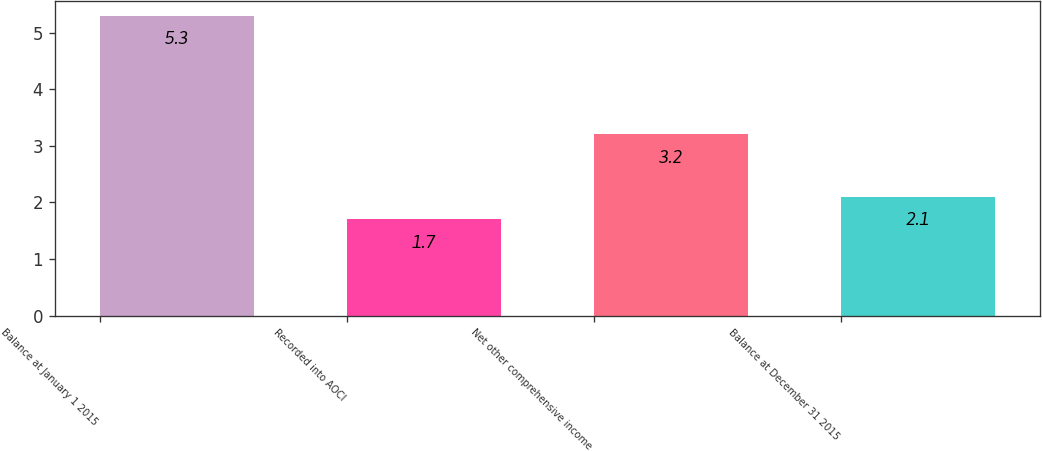Convert chart. <chart><loc_0><loc_0><loc_500><loc_500><bar_chart><fcel>Balance at January 1 2015<fcel>Recorded into AOCI<fcel>Net other comprehensive income<fcel>Balance at December 31 2015<nl><fcel>5.3<fcel>1.7<fcel>3.2<fcel>2.1<nl></chart> 